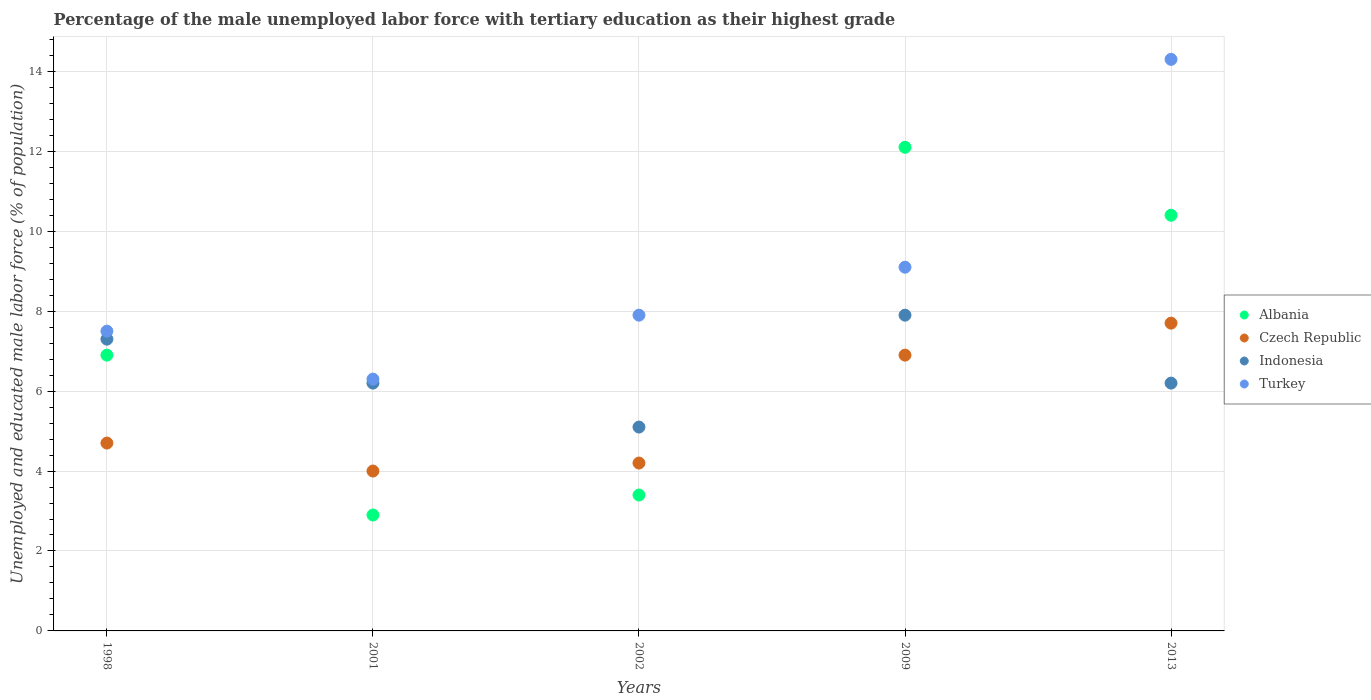What is the percentage of the unemployed male labor force with tertiary education in Indonesia in 2009?
Your answer should be compact. 7.9. Across all years, what is the maximum percentage of the unemployed male labor force with tertiary education in Indonesia?
Provide a succinct answer. 7.9. Across all years, what is the minimum percentage of the unemployed male labor force with tertiary education in Indonesia?
Offer a terse response. 5.1. What is the total percentage of the unemployed male labor force with tertiary education in Indonesia in the graph?
Give a very brief answer. 32.7. What is the difference between the percentage of the unemployed male labor force with tertiary education in Indonesia in 1998 and that in 2009?
Ensure brevity in your answer.  -0.6. What is the difference between the percentage of the unemployed male labor force with tertiary education in Indonesia in 1998 and the percentage of the unemployed male labor force with tertiary education in Albania in 2002?
Provide a short and direct response. 3.9. What is the average percentage of the unemployed male labor force with tertiary education in Czech Republic per year?
Keep it short and to the point. 5.5. In the year 2001, what is the difference between the percentage of the unemployed male labor force with tertiary education in Turkey and percentage of the unemployed male labor force with tertiary education in Albania?
Your answer should be compact. 3.4. In how many years, is the percentage of the unemployed male labor force with tertiary education in Turkey greater than 2.4 %?
Give a very brief answer. 5. What is the ratio of the percentage of the unemployed male labor force with tertiary education in Albania in 1998 to that in 2013?
Give a very brief answer. 0.66. Is the percentage of the unemployed male labor force with tertiary education in Czech Republic in 1998 less than that in 2001?
Your response must be concise. No. Is the difference between the percentage of the unemployed male labor force with tertiary education in Turkey in 2009 and 2013 greater than the difference between the percentage of the unemployed male labor force with tertiary education in Albania in 2009 and 2013?
Ensure brevity in your answer.  No. What is the difference between the highest and the second highest percentage of the unemployed male labor force with tertiary education in Turkey?
Your response must be concise. 5.2. What is the difference between the highest and the lowest percentage of the unemployed male labor force with tertiary education in Indonesia?
Keep it short and to the point. 2.8. Is the sum of the percentage of the unemployed male labor force with tertiary education in Czech Republic in 1998 and 2009 greater than the maximum percentage of the unemployed male labor force with tertiary education in Turkey across all years?
Give a very brief answer. No. Is it the case that in every year, the sum of the percentage of the unemployed male labor force with tertiary education in Czech Republic and percentage of the unemployed male labor force with tertiary education in Indonesia  is greater than the sum of percentage of the unemployed male labor force with tertiary education in Albania and percentage of the unemployed male labor force with tertiary education in Turkey?
Give a very brief answer. No. Is the percentage of the unemployed male labor force with tertiary education in Indonesia strictly less than the percentage of the unemployed male labor force with tertiary education in Albania over the years?
Make the answer very short. No. Are the values on the major ticks of Y-axis written in scientific E-notation?
Your answer should be very brief. No. Does the graph contain any zero values?
Give a very brief answer. No. Does the graph contain grids?
Make the answer very short. Yes. Where does the legend appear in the graph?
Your answer should be compact. Center right. How many legend labels are there?
Provide a short and direct response. 4. What is the title of the graph?
Offer a terse response. Percentage of the male unemployed labor force with tertiary education as their highest grade. What is the label or title of the Y-axis?
Provide a short and direct response. Unemployed and educated male labor force (% of population). What is the Unemployed and educated male labor force (% of population) of Albania in 1998?
Your answer should be compact. 6.9. What is the Unemployed and educated male labor force (% of population) in Czech Republic in 1998?
Keep it short and to the point. 4.7. What is the Unemployed and educated male labor force (% of population) in Indonesia in 1998?
Make the answer very short. 7.3. What is the Unemployed and educated male labor force (% of population) in Turkey in 1998?
Offer a very short reply. 7.5. What is the Unemployed and educated male labor force (% of population) of Albania in 2001?
Your answer should be compact. 2.9. What is the Unemployed and educated male labor force (% of population) of Indonesia in 2001?
Your answer should be very brief. 6.2. What is the Unemployed and educated male labor force (% of population) of Turkey in 2001?
Offer a very short reply. 6.3. What is the Unemployed and educated male labor force (% of population) of Albania in 2002?
Offer a very short reply. 3.4. What is the Unemployed and educated male labor force (% of population) of Czech Republic in 2002?
Your answer should be very brief. 4.2. What is the Unemployed and educated male labor force (% of population) of Indonesia in 2002?
Offer a very short reply. 5.1. What is the Unemployed and educated male labor force (% of population) of Turkey in 2002?
Ensure brevity in your answer.  7.9. What is the Unemployed and educated male labor force (% of population) of Albania in 2009?
Your answer should be compact. 12.1. What is the Unemployed and educated male labor force (% of population) of Czech Republic in 2009?
Keep it short and to the point. 6.9. What is the Unemployed and educated male labor force (% of population) of Indonesia in 2009?
Provide a succinct answer. 7.9. What is the Unemployed and educated male labor force (% of population) of Turkey in 2009?
Make the answer very short. 9.1. What is the Unemployed and educated male labor force (% of population) in Albania in 2013?
Make the answer very short. 10.4. What is the Unemployed and educated male labor force (% of population) of Czech Republic in 2013?
Ensure brevity in your answer.  7.7. What is the Unemployed and educated male labor force (% of population) of Indonesia in 2013?
Offer a very short reply. 6.2. What is the Unemployed and educated male labor force (% of population) in Turkey in 2013?
Give a very brief answer. 14.3. Across all years, what is the maximum Unemployed and educated male labor force (% of population) of Albania?
Your answer should be very brief. 12.1. Across all years, what is the maximum Unemployed and educated male labor force (% of population) in Czech Republic?
Ensure brevity in your answer.  7.7. Across all years, what is the maximum Unemployed and educated male labor force (% of population) in Indonesia?
Offer a very short reply. 7.9. Across all years, what is the maximum Unemployed and educated male labor force (% of population) in Turkey?
Provide a succinct answer. 14.3. Across all years, what is the minimum Unemployed and educated male labor force (% of population) of Albania?
Ensure brevity in your answer.  2.9. Across all years, what is the minimum Unemployed and educated male labor force (% of population) in Czech Republic?
Your answer should be very brief. 4. Across all years, what is the minimum Unemployed and educated male labor force (% of population) of Indonesia?
Offer a very short reply. 5.1. Across all years, what is the minimum Unemployed and educated male labor force (% of population) in Turkey?
Offer a terse response. 6.3. What is the total Unemployed and educated male labor force (% of population) of Albania in the graph?
Keep it short and to the point. 35.7. What is the total Unemployed and educated male labor force (% of population) of Indonesia in the graph?
Your answer should be compact. 32.7. What is the total Unemployed and educated male labor force (% of population) of Turkey in the graph?
Offer a terse response. 45.1. What is the difference between the Unemployed and educated male labor force (% of population) of Albania in 1998 and that in 2001?
Provide a short and direct response. 4. What is the difference between the Unemployed and educated male labor force (% of population) in Indonesia in 1998 and that in 2001?
Your response must be concise. 1.1. What is the difference between the Unemployed and educated male labor force (% of population) of Turkey in 1998 and that in 2001?
Your response must be concise. 1.2. What is the difference between the Unemployed and educated male labor force (% of population) in Albania in 1998 and that in 2002?
Offer a terse response. 3.5. What is the difference between the Unemployed and educated male labor force (% of population) in Czech Republic in 1998 and that in 2002?
Give a very brief answer. 0.5. What is the difference between the Unemployed and educated male labor force (% of population) in Indonesia in 1998 and that in 2002?
Offer a terse response. 2.2. What is the difference between the Unemployed and educated male labor force (% of population) of Albania in 1998 and that in 2009?
Provide a succinct answer. -5.2. What is the difference between the Unemployed and educated male labor force (% of population) of Albania in 1998 and that in 2013?
Your response must be concise. -3.5. What is the difference between the Unemployed and educated male labor force (% of population) in Czech Republic in 1998 and that in 2013?
Your answer should be very brief. -3. What is the difference between the Unemployed and educated male labor force (% of population) in Indonesia in 1998 and that in 2013?
Give a very brief answer. 1.1. What is the difference between the Unemployed and educated male labor force (% of population) in Turkey in 1998 and that in 2013?
Your answer should be compact. -6.8. What is the difference between the Unemployed and educated male labor force (% of population) in Albania in 2001 and that in 2002?
Your answer should be compact. -0.5. What is the difference between the Unemployed and educated male labor force (% of population) in Czech Republic in 2001 and that in 2002?
Keep it short and to the point. -0.2. What is the difference between the Unemployed and educated male labor force (% of population) in Czech Republic in 2001 and that in 2009?
Offer a terse response. -2.9. What is the difference between the Unemployed and educated male labor force (% of population) in Turkey in 2001 and that in 2009?
Ensure brevity in your answer.  -2.8. What is the difference between the Unemployed and educated male labor force (% of population) of Albania in 2001 and that in 2013?
Give a very brief answer. -7.5. What is the difference between the Unemployed and educated male labor force (% of population) of Czech Republic in 2001 and that in 2013?
Offer a terse response. -3.7. What is the difference between the Unemployed and educated male labor force (% of population) in Indonesia in 2001 and that in 2013?
Give a very brief answer. 0. What is the difference between the Unemployed and educated male labor force (% of population) of Turkey in 2001 and that in 2013?
Ensure brevity in your answer.  -8. What is the difference between the Unemployed and educated male labor force (% of population) in Albania in 2002 and that in 2009?
Provide a succinct answer. -8.7. What is the difference between the Unemployed and educated male labor force (% of population) in Czech Republic in 2002 and that in 2009?
Keep it short and to the point. -2.7. What is the difference between the Unemployed and educated male labor force (% of population) of Indonesia in 2002 and that in 2009?
Your answer should be very brief. -2.8. What is the difference between the Unemployed and educated male labor force (% of population) of Czech Republic in 2002 and that in 2013?
Offer a very short reply. -3.5. What is the difference between the Unemployed and educated male labor force (% of population) in Indonesia in 2002 and that in 2013?
Make the answer very short. -1.1. What is the difference between the Unemployed and educated male labor force (% of population) in Indonesia in 2009 and that in 2013?
Keep it short and to the point. 1.7. What is the difference between the Unemployed and educated male labor force (% of population) in Turkey in 2009 and that in 2013?
Ensure brevity in your answer.  -5.2. What is the difference between the Unemployed and educated male labor force (% of population) in Albania in 1998 and the Unemployed and educated male labor force (% of population) in Czech Republic in 2001?
Ensure brevity in your answer.  2.9. What is the difference between the Unemployed and educated male labor force (% of population) in Czech Republic in 1998 and the Unemployed and educated male labor force (% of population) in Indonesia in 2001?
Provide a short and direct response. -1.5. What is the difference between the Unemployed and educated male labor force (% of population) of Czech Republic in 1998 and the Unemployed and educated male labor force (% of population) of Indonesia in 2002?
Provide a succinct answer. -0.4. What is the difference between the Unemployed and educated male labor force (% of population) in Czech Republic in 1998 and the Unemployed and educated male labor force (% of population) in Turkey in 2002?
Provide a succinct answer. -3.2. What is the difference between the Unemployed and educated male labor force (% of population) of Albania in 1998 and the Unemployed and educated male labor force (% of population) of Indonesia in 2009?
Provide a succinct answer. -1. What is the difference between the Unemployed and educated male labor force (% of population) of Albania in 1998 and the Unemployed and educated male labor force (% of population) of Indonesia in 2013?
Ensure brevity in your answer.  0.7. What is the difference between the Unemployed and educated male labor force (% of population) in Czech Republic in 1998 and the Unemployed and educated male labor force (% of population) in Indonesia in 2013?
Your answer should be compact. -1.5. What is the difference between the Unemployed and educated male labor force (% of population) in Indonesia in 1998 and the Unemployed and educated male labor force (% of population) in Turkey in 2013?
Your response must be concise. -7. What is the difference between the Unemployed and educated male labor force (% of population) of Albania in 2001 and the Unemployed and educated male labor force (% of population) of Indonesia in 2002?
Your response must be concise. -2.2. What is the difference between the Unemployed and educated male labor force (% of population) in Czech Republic in 2001 and the Unemployed and educated male labor force (% of population) in Turkey in 2002?
Keep it short and to the point. -3.9. What is the difference between the Unemployed and educated male labor force (% of population) in Albania in 2001 and the Unemployed and educated male labor force (% of population) in Czech Republic in 2009?
Ensure brevity in your answer.  -4. What is the difference between the Unemployed and educated male labor force (% of population) of Albania in 2001 and the Unemployed and educated male labor force (% of population) of Indonesia in 2009?
Make the answer very short. -5. What is the difference between the Unemployed and educated male labor force (% of population) in Albania in 2001 and the Unemployed and educated male labor force (% of population) in Turkey in 2009?
Give a very brief answer. -6.2. What is the difference between the Unemployed and educated male labor force (% of population) of Czech Republic in 2001 and the Unemployed and educated male labor force (% of population) of Indonesia in 2009?
Provide a short and direct response. -3.9. What is the difference between the Unemployed and educated male labor force (% of population) in Czech Republic in 2001 and the Unemployed and educated male labor force (% of population) in Turkey in 2013?
Your response must be concise. -10.3. What is the difference between the Unemployed and educated male labor force (% of population) of Albania in 2002 and the Unemployed and educated male labor force (% of population) of Indonesia in 2009?
Ensure brevity in your answer.  -4.5. What is the difference between the Unemployed and educated male labor force (% of population) in Albania in 2002 and the Unemployed and educated male labor force (% of population) in Czech Republic in 2013?
Make the answer very short. -4.3. What is the difference between the Unemployed and educated male labor force (% of population) in Albania in 2002 and the Unemployed and educated male labor force (% of population) in Indonesia in 2013?
Offer a terse response. -2.8. What is the difference between the Unemployed and educated male labor force (% of population) in Czech Republic in 2002 and the Unemployed and educated male labor force (% of population) in Turkey in 2013?
Your response must be concise. -10.1. What is the difference between the Unemployed and educated male labor force (% of population) in Indonesia in 2002 and the Unemployed and educated male labor force (% of population) in Turkey in 2013?
Make the answer very short. -9.2. What is the difference between the Unemployed and educated male labor force (% of population) in Albania in 2009 and the Unemployed and educated male labor force (% of population) in Indonesia in 2013?
Make the answer very short. 5.9. What is the difference between the Unemployed and educated male labor force (% of population) of Indonesia in 2009 and the Unemployed and educated male labor force (% of population) of Turkey in 2013?
Keep it short and to the point. -6.4. What is the average Unemployed and educated male labor force (% of population) of Albania per year?
Provide a succinct answer. 7.14. What is the average Unemployed and educated male labor force (% of population) of Indonesia per year?
Give a very brief answer. 6.54. What is the average Unemployed and educated male labor force (% of population) in Turkey per year?
Offer a very short reply. 9.02. In the year 1998, what is the difference between the Unemployed and educated male labor force (% of population) of Albania and Unemployed and educated male labor force (% of population) of Indonesia?
Make the answer very short. -0.4. In the year 1998, what is the difference between the Unemployed and educated male labor force (% of population) of Czech Republic and Unemployed and educated male labor force (% of population) of Indonesia?
Keep it short and to the point. -2.6. In the year 1998, what is the difference between the Unemployed and educated male labor force (% of population) in Indonesia and Unemployed and educated male labor force (% of population) in Turkey?
Your answer should be very brief. -0.2. In the year 2001, what is the difference between the Unemployed and educated male labor force (% of population) of Czech Republic and Unemployed and educated male labor force (% of population) of Indonesia?
Offer a terse response. -2.2. In the year 2001, what is the difference between the Unemployed and educated male labor force (% of population) of Czech Republic and Unemployed and educated male labor force (% of population) of Turkey?
Keep it short and to the point. -2.3. In the year 2002, what is the difference between the Unemployed and educated male labor force (% of population) in Albania and Unemployed and educated male labor force (% of population) in Indonesia?
Provide a short and direct response. -1.7. In the year 2002, what is the difference between the Unemployed and educated male labor force (% of population) of Czech Republic and Unemployed and educated male labor force (% of population) of Turkey?
Your answer should be compact. -3.7. In the year 2002, what is the difference between the Unemployed and educated male labor force (% of population) in Indonesia and Unemployed and educated male labor force (% of population) in Turkey?
Provide a succinct answer. -2.8. In the year 2009, what is the difference between the Unemployed and educated male labor force (% of population) in Albania and Unemployed and educated male labor force (% of population) in Indonesia?
Offer a terse response. 4.2. In the year 2009, what is the difference between the Unemployed and educated male labor force (% of population) in Albania and Unemployed and educated male labor force (% of population) in Turkey?
Provide a short and direct response. 3. In the year 2013, what is the difference between the Unemployed and educated male labor force (% of population) of Albania and Unemployed and educated male labor force (% of population) of Czech Republic?
Give a very brief answer. 2.7. In the year 2013, what is the difference between the Unemployed and educated male labor force (% of population) of Albania and Unemployed and educated male labor force (% of population) of Turkey?
Your answer should be compact. -3.9. In the year 2013, what is the difference between the Unemployed and educated male labor force (% of population) of Czech Republic and Unemployed and educated male labor force (% of population) of Indonesia?
Offer a very short reply. 1.5. In the year 2013, what is the difference between the Unemployed and educated male labor force (% of population) of Czech Republic and Unemployed and educated male labor force (% of population) of Turkey?
Keep it short and to the point. -6.6. In the year 2013, what is the difference between the Unemployed and educated male labor force (% of population) of Indonesia and Unemployed and educated male labor force (% of population) of Turkey?
Your response must be concise. -8.1. What is the ratio of the Unemployed and educated male labor force (% of population) of Albania in 1998 to that in 2001?
Your response must be concise. 2.38. What is the ratio of the Unemployed and educated male labor force (% of population) of Czech Republic in 1998 to that in 2001?
Your response must be concise. 1.18. What is the ratio of the Unemployed and educated male labor force (% of population) in Indonesia in 1998 to that in 2001?
Offer a terse response. 1.18. What is the ratio of the Unemployed and educated male labor force (% of population) in Turkey in 1998 to that in 2001?
Provide a succinct answer. 1.19. What is the ratio of the Unemployed and educated male labor force (% of population) of Albania in 1998 to that in 2002?
Provide a short and direct response. 2.03. What is the ratio of the Unemployed and educated male labor force (% of population) of Czech Republic in 1998 to that in 2002?
Ensure brevity in your answer.  1.12. What is the ratio of the Unemployed and educated male labor force (% of population) in Indonesia in 1998 to that in 2002?
Your answer should be compact. 1.43. What is the ratio of the Unemployed and educated male labor force (% of population) of Turkey in 1998 to that in 2002?
Make the answer very short. 0.95. What is the ratio of the Unemployed and educated male labor force (% of population) in Albania in 1998 to that in 2009?
Your answer should be very brief. 0.57. What is the ratio of the Unemployed and educated male labor force (% of population) of Czech Republic in 1998 to that in 2009?
Give a very brief answer. 0.68. What is the ratio of the Unemployed and educated male labor force (% of population) of Indonesia in 1998 to that in 2009?
Your response must be concise. 0.92. What is the ratio of the Unemployed and educated male labor force (% of population) in Turkey in 1998 to that in 2009?
Provide a short and direct response. 0.82. What is the ratio of the Unemployed and educated male labor force (% of population) of Albania in 1998 to that in 2013?
Provide a succinct answer. 0.66. What is the ratio of the Unemployed and educated male labor force (% of population) of Czech Republic in 1998 to that in 2013?
Your answer should be very brief. 0.61. What is the ratio of the Unemployed and educated male labor force (% of population) of Indonesia in 1998 to that in 2013?
Give a very brief answer. 1.18. What is the ratio of the Unemployed and educated male labor force (% of population) of Turkey in 1998 to that in 2013?
Give a very brief answer. 0.52. What is the ratio of the Unemployed and educated male labor force (% of population) of Albania in 2001 to that in 2002?
Your answer should be compact. 0.85. What is the ratio of the Unemployed and educated male labor force (% of population) of Czech Republic in 2001 to that in 2002?
Your answer should be very brief. 0.95. What is the ratio of the Unemployed and educated male labor force (% of population) in Indonesia in 2001 to that in 2002?
Your response must be concise. 1.22. What is the ratio of the Unemployed and educated male labor force (% of population) in Turkey in 2001 to that in 2002?
Your answer should be very brief. 0.8. What is the ratio of the Unemployed and educated male labor force (% of population) in Albania in 2001 to that in 2009?
Offer a very short reply. 0.24. What is the ratio of the Unemployed and educated male labor force (% of population) in Czech Republic in 2001 to that in 2009?
Provide a short and direct response. 0.58. What is the ratio of the Unemployed and educated male labor force (% of population) of Indonesia in 2001 to that in 2009?
Give a very brief answer. 0.78. What is the ratio of the Unemployed and educated male labor force (% of population) of Turkey in 2001 to that in 2009?
Give a very brief answer. 0.69. What is the ratio of the Unemployed and educated male labor force (% of population) in Albania in 2001 to that in 2013?
Your answer should be compact. 0.28. What is the ratio of the Unemployed and educated male labor force (% of population) in Czech Republic in 2001 to that in 2013?
Your response must be concise. 0.52. What is the ratio of the Unemployed and educated male labor force (% of population) of Turkey in 2001 to that in 2013?
Give a very brief answer. 0.44. What is the ratio of the Unemployed and educated male labor force (% of population) of Albania in 2002 to that in 2009?
Your answer should be very brief. 0.28. What is the ratio of the Unemployed and educated male labor force (% of population) of Czech Republic in 2002 to that in 2009?
Make the answer very short. 0.61. What is the ratio of the Unemployed and educated male labor force (% of population) in Indonesia in 2002 to that in 2009?
Offer a terse response. 0.65. What is the ratio of the Unemployed and educated male labor force (% of population) of Turkey in 2002 to that in 2009?
Offer a terse response. 0.87. What is the ratio of the Unemployed and educated male labor force (% of population) in Albania in 2002 to that in 2013?
Your answer should be compact. 0.33. What is the ratio of the Unemployed and educated male labor force (% of population) of Czech Republic in 2002 to that in 2013?
Your response must be concise. 0.55. What is the ratio of the Unemployed and educated male labor force (% of population) of Indonesia in 2002 to that in 2013?
Your answer should be compact. 0.82. What is the ratio of the Unemployed and educated male labor force (% of population) of Turkey in 2002 to that in 2013?
Offer a terse response. 0.55. What is the ratio of the Unemployed and educated male labor force (% of population) in Albania in 2009 to that in 2013?
Your answer should be very brief. 1.16. What is the ratio of the Unemployed and educated male labor force (% of population) in Czech Republic in 2009 to that in 2013?
Your response must be concise. 0.9. What is the ratio of the Unemployed and educated male labor force (% of population) of Indonesia in 2009 to that in 2013?
Give a very brief answer. 1.27. What is the ratio of the Unemployed and educated male labor force (% of population) of Turkey in 2009 to that in 2013?
Offer a terse response. 0.64. What is the difference between the highest and the second highest Unemployed and educated male labor force (% of population) in Indonesia?
Offer a terse response. 0.6. What is the difference between the highest and the lowest Unemployed and educated male labor force (% of population) of Albania?
Provide a succinct answer. 9.2. What is the difference between the highest and the lowest Unemployed and educated male labor force (% of population) in Czech Republic?
Keep it short and to the point. 3.7. 